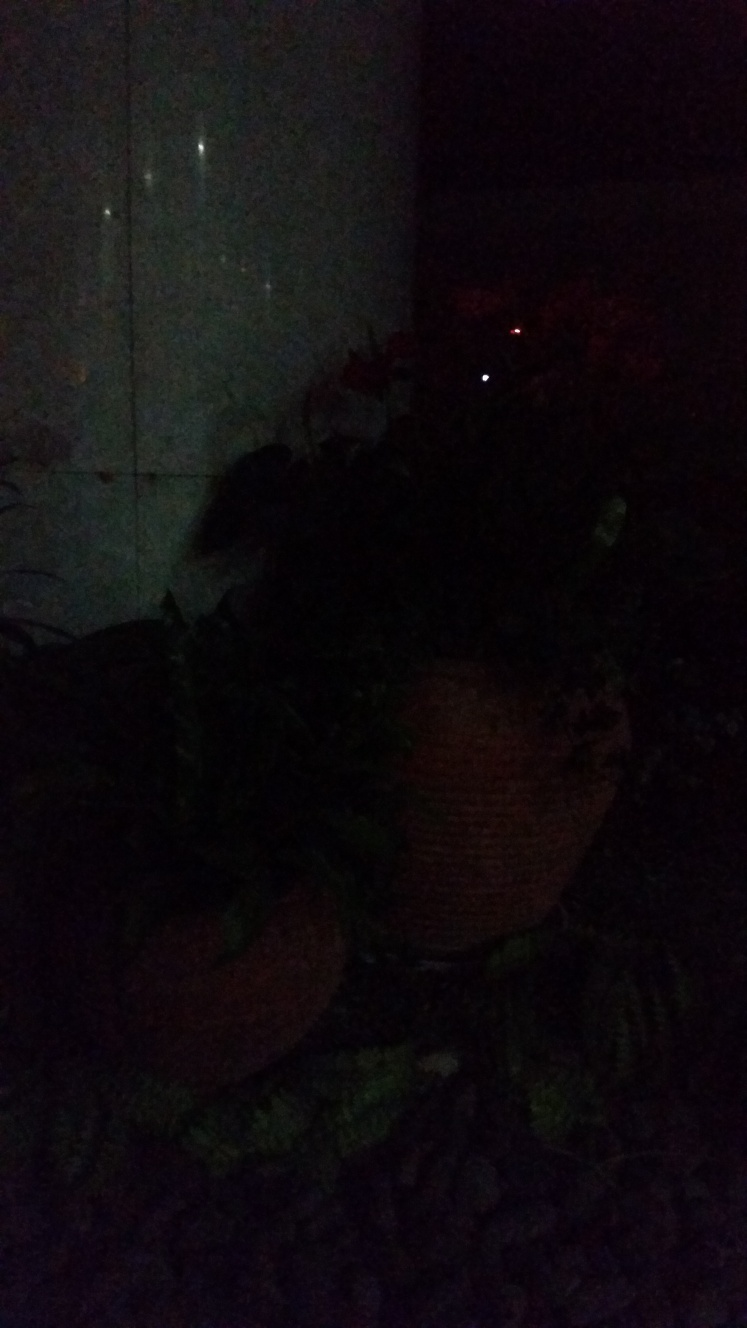Can you tell what time of day it might be based on the image? Given the darkness in the image, it's likely taken at night or in very low light conditions. What can be done to improve the visibility of the image? Improving visibility could involve using a flash or additional lighting when taking the photo, increasing the exposure settings on the camera, or using photo editing software to brighten the image and enhance details post-capture. 